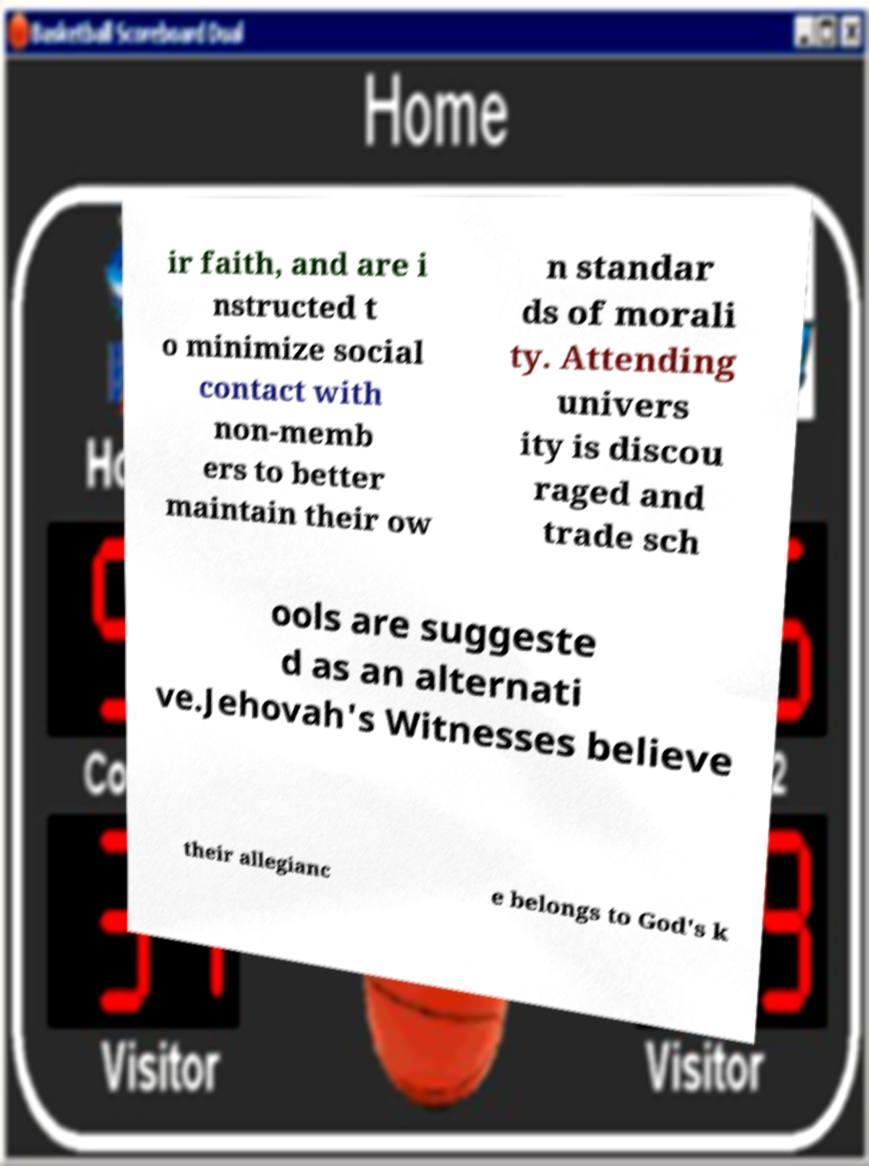Could you assist in decoding the text presented in this image and type it out clearly? ir faith, and are i nstructed t o minimize social contact with non-memb ers to better maintain their ow n standar ds of morali ty. Attending univers ity is discou raged and trade sch ools are suggeste d as an alternati ve.Jehovah's Witnesses believe their allegianc e belongs to God's k 